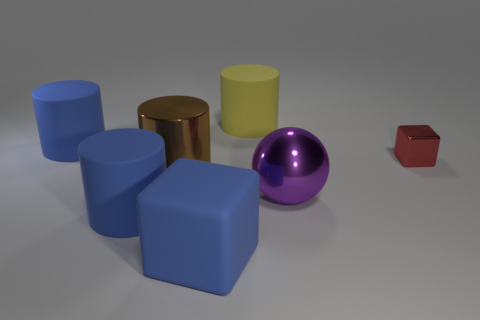Is the color of the large block the same as the matte cylinder in front of the small red shiny thing?
Keep it short and to the point. Yes. There is another object that is the same shape as the tiny thing; what size is it?
Ensure brevity in your answer.  Large. Do the large metal thing that is to the left of the big rubber block and the yellow object have the same shape?
Make the answer very short. Yes. There is a large rubber cylinder that is in front of the tiny metal object; what color is it?
Your response must be concise. Blue. How many other objects are the same size as the brown thing?
Your answer should be very brief. 5. Is there any other thing that has the same shape as the large yellow object?
Offer a terse response. Yes. Are there the same number of big blue things right of the large purple object and rubber things?
Provide a short and direct response. No. How many big objects have the same material as the big block?
Provide a short and direct response. 3. What color is the large ball that is made of the same material as the big brown cylinder?
Ensure brevity in your answer.  Purple. Is the yellow matte object the same shape as the big brown shiny object?
Your answer should be compact. Yes. 